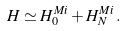Convert formula to latex. <formula><loc_0><loc_0><loc_500><loc_500>H \simeq H _ { 0 } ^ { M i } + H _ { N } ^ { M i } \, .</formula> 